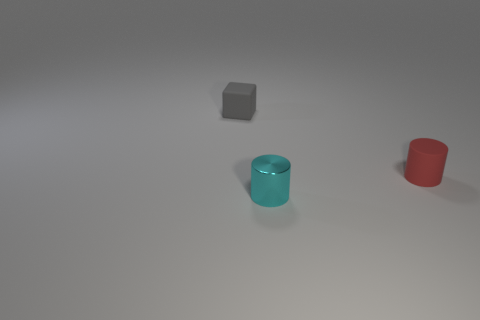Add 1 cyan shiny cylinders. How many objects exist? 4 Subtract all blocks. How many objects are left? 2 Add 2 shiny cylinders. How many shiny cylinders are left? 3 Add 2 small metallic cylinders. How many small metallic cylinders exist? 3 Subtract 0 green cylinders. How many objects are left? 3 Subtract all spheres. Subtract all small things. How many objects are left? 0 